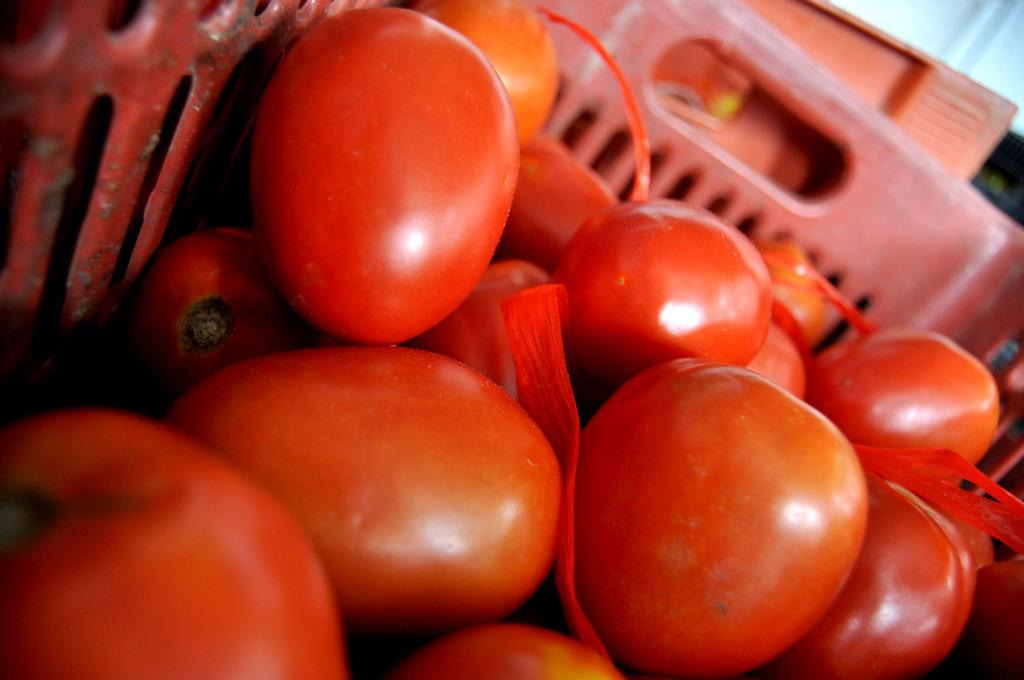What object can be seen in the image? There is a basket in the image. What is inside the basket? The basket contains tomatoes. How many circles can be seen in the image? There is no circle present in the image. What type of frogs are hopping around the tomatoes in the basket? There are no frogs present in the image; it only contains a basket of tomatoes. 